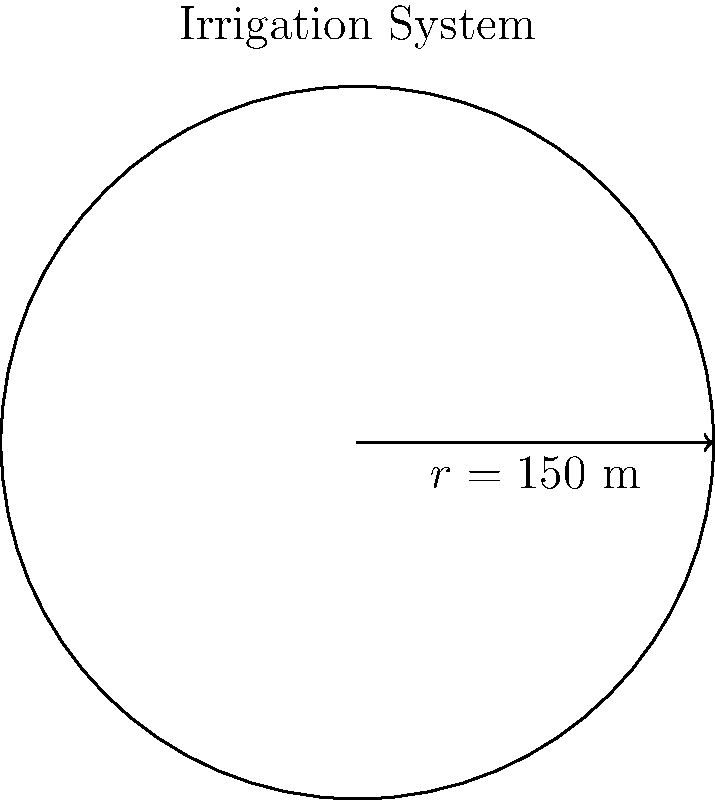You've installed a circular center pivot irrigation system on your farm. The system has a radius of 150 meters. What is the total area that can be irrigated by this system? To find the area of the circular irrigation system, we need to use the formula for the area of a circle:

$$ A = \pi r^2 $$

Where:
$A$ is the area
$\pi$ (pi) is approximately 3.14159
$r$ is the radius

Given:
$r = 150$ meters

Let's substitute this into our formula:

$$ A = \pi (150\text{ m})^2 $$

$$ A = \pi (22,500\text{ m}^2) $$

$$ A \approx 3.14159 \times 22,500\text{ m}^2 $$

$$ A \approx 70,685.775\text{ m}^2 $$

Rounding to the nearest whole number:

$$ A \approx 70,686\text{ m}^2 $$

Therefore, the total area that can be irrigated by this system is approximately 70,686 square meters.
Answer: 70,686 m² 